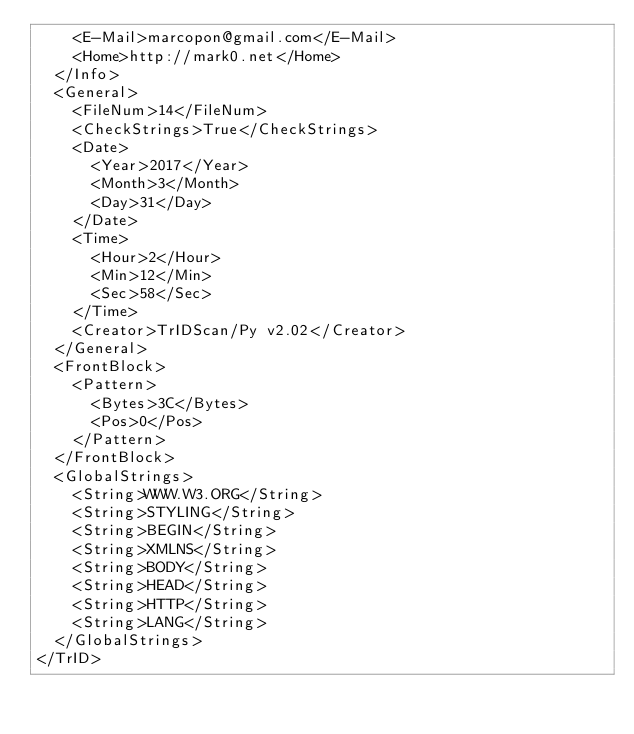Convert code to text. <code><loc_0><loc_0><loc_500><loc_500><_XML_>		<E-Mail>marcopon@gmail.com</E-Mail>
		<Home>http://mark0.net</Home>
	</Info>
	<General>
		<FileNum>14</FileNum>
		<CheckStrings>True</CheckStrings>
		<Date>
			<Year>2017</Year>
			<Month>3</Month>
			<Day>31</Day>
		</Date>
		<Time>
			<Hour>2</Hour>
			<Min>12</Min>
			<Sec>58</Sec>
		</Time>
		<Creator>TrIDScan/Py v2.02</Creator>
	</General>
	<FrontBlock>
		<Pattern>
			<Bytes>3C</Bytes>
			<Pos>0</Pos>
		</Pattern>
	</FrontBlock>
	<GlobalStrings>
		<String>WWW.W3.ORG</String>
		<String>STYLING</String>
		<String>BEGIN</String>
		<String>XMLNS</String>
		<String>BODY</String>
		<String>HEAD</String>
		<String>HTTP</String>
		<String>LANG</String>
	</GlobalStrings>
</TrID></code> 